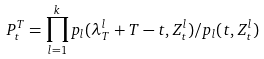Convert formula to latex. <formula><loc_0><loc_0><loc_500><loc_500>P ^ { T } _ { t } = \prod _ { l = 1 } ^ { k } p _ { l } ( \lambda ^ { l } _ { T } + T - t , Z ^ { l } _ { t } ) / p _ { l } ( t , Z ^ { l } _ { t } )</formula> 